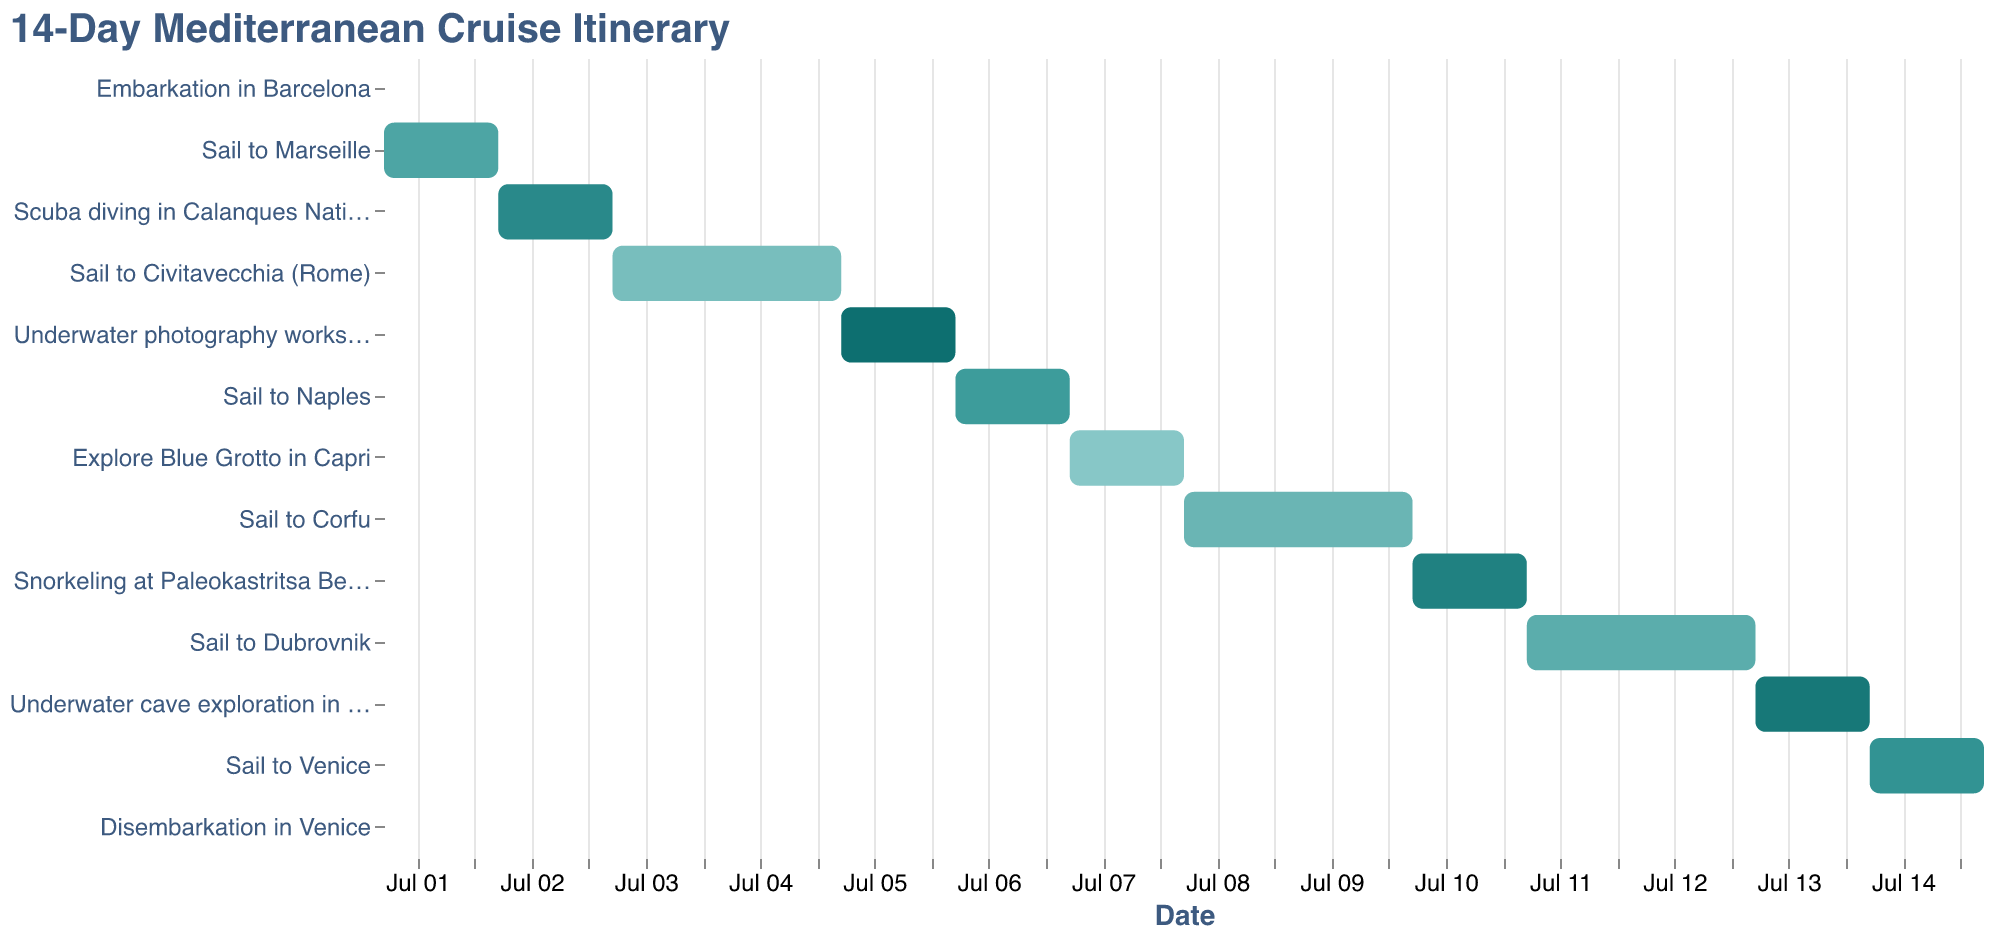What is the title of the Gantt Chart? The title is typically displayed at the top of the chart. In this Gantt chart, the title reads "14-Day Mediterranean Cruise Itinerary".
Answer: 14-Day Mediterranean Cruise Itinerary How many distinct activities are there in the itinerary? The Gantt chart lists each activity as a bar. Counting all the distinct activities listed in the y-axis will give the total number of unique tasks.
Answer: 13 On which date does the underwater photography workshop end? Locate the "Underwater photography workshop" bar on the Gantt chart and find its end date on the x-axis.
Answer: 2023-07-06 How many days are spent in sailing activities (excluding activities at stops)? Identify all tasks with “Sail to” in their names and sum the durations for each sailing activity. These are: Sail to Marseille (1 day), Sail to Civitavecchia (2 days), Sail to Naples (1 day), Sail to Corfu (2 days), Sail to Dubrovnik (2 days), Sail to Venice (1 day).
Answer: 9 days Which activity immediately follows "Scuba diving in Calanques National Park"? Find the end date of "Scuba diving in Calanques National Park" on the Gantt chart and identify the task that starts right after that end date.
Answer: Sail to Civitavecchia (Rome) On what dates does snorkeling at Paleokastritsa Beach take place? Locate the "Snorkeling at Paleokastritsa Beach" bar on the y-axis and check its start and end dates on the x-axis.
Answer: 2023-07-10 to 2023-07-11 What is the total number of days spent on water-based excursions (not including sailing)? Identify all water-based activities: Scuba diving (1 day), Underwater photography workshop (1 day), Explore Blue Grotto (1 day), Snorkeling (1 day), Underwater cave exploration (1 day). Sum their durations.
Answer: 5 days Which stop has the longest underwater activity? Compare the durations of all underwater activities. "Underwater cave exploration in Lokrum Island" has the longest duration as it spans from 2023-07-13 to 2023-07-14.
Answer: Lokrum Island How many days are spent between embarkation in Barcelona and the first underwater activity? The embarkation in Barcelona is on 2023-07-01, and the first underwater activity, Scuba diving in Calanques National Park, occurs on 2023-07-02. Count the days in between.
Answer: 1 day 